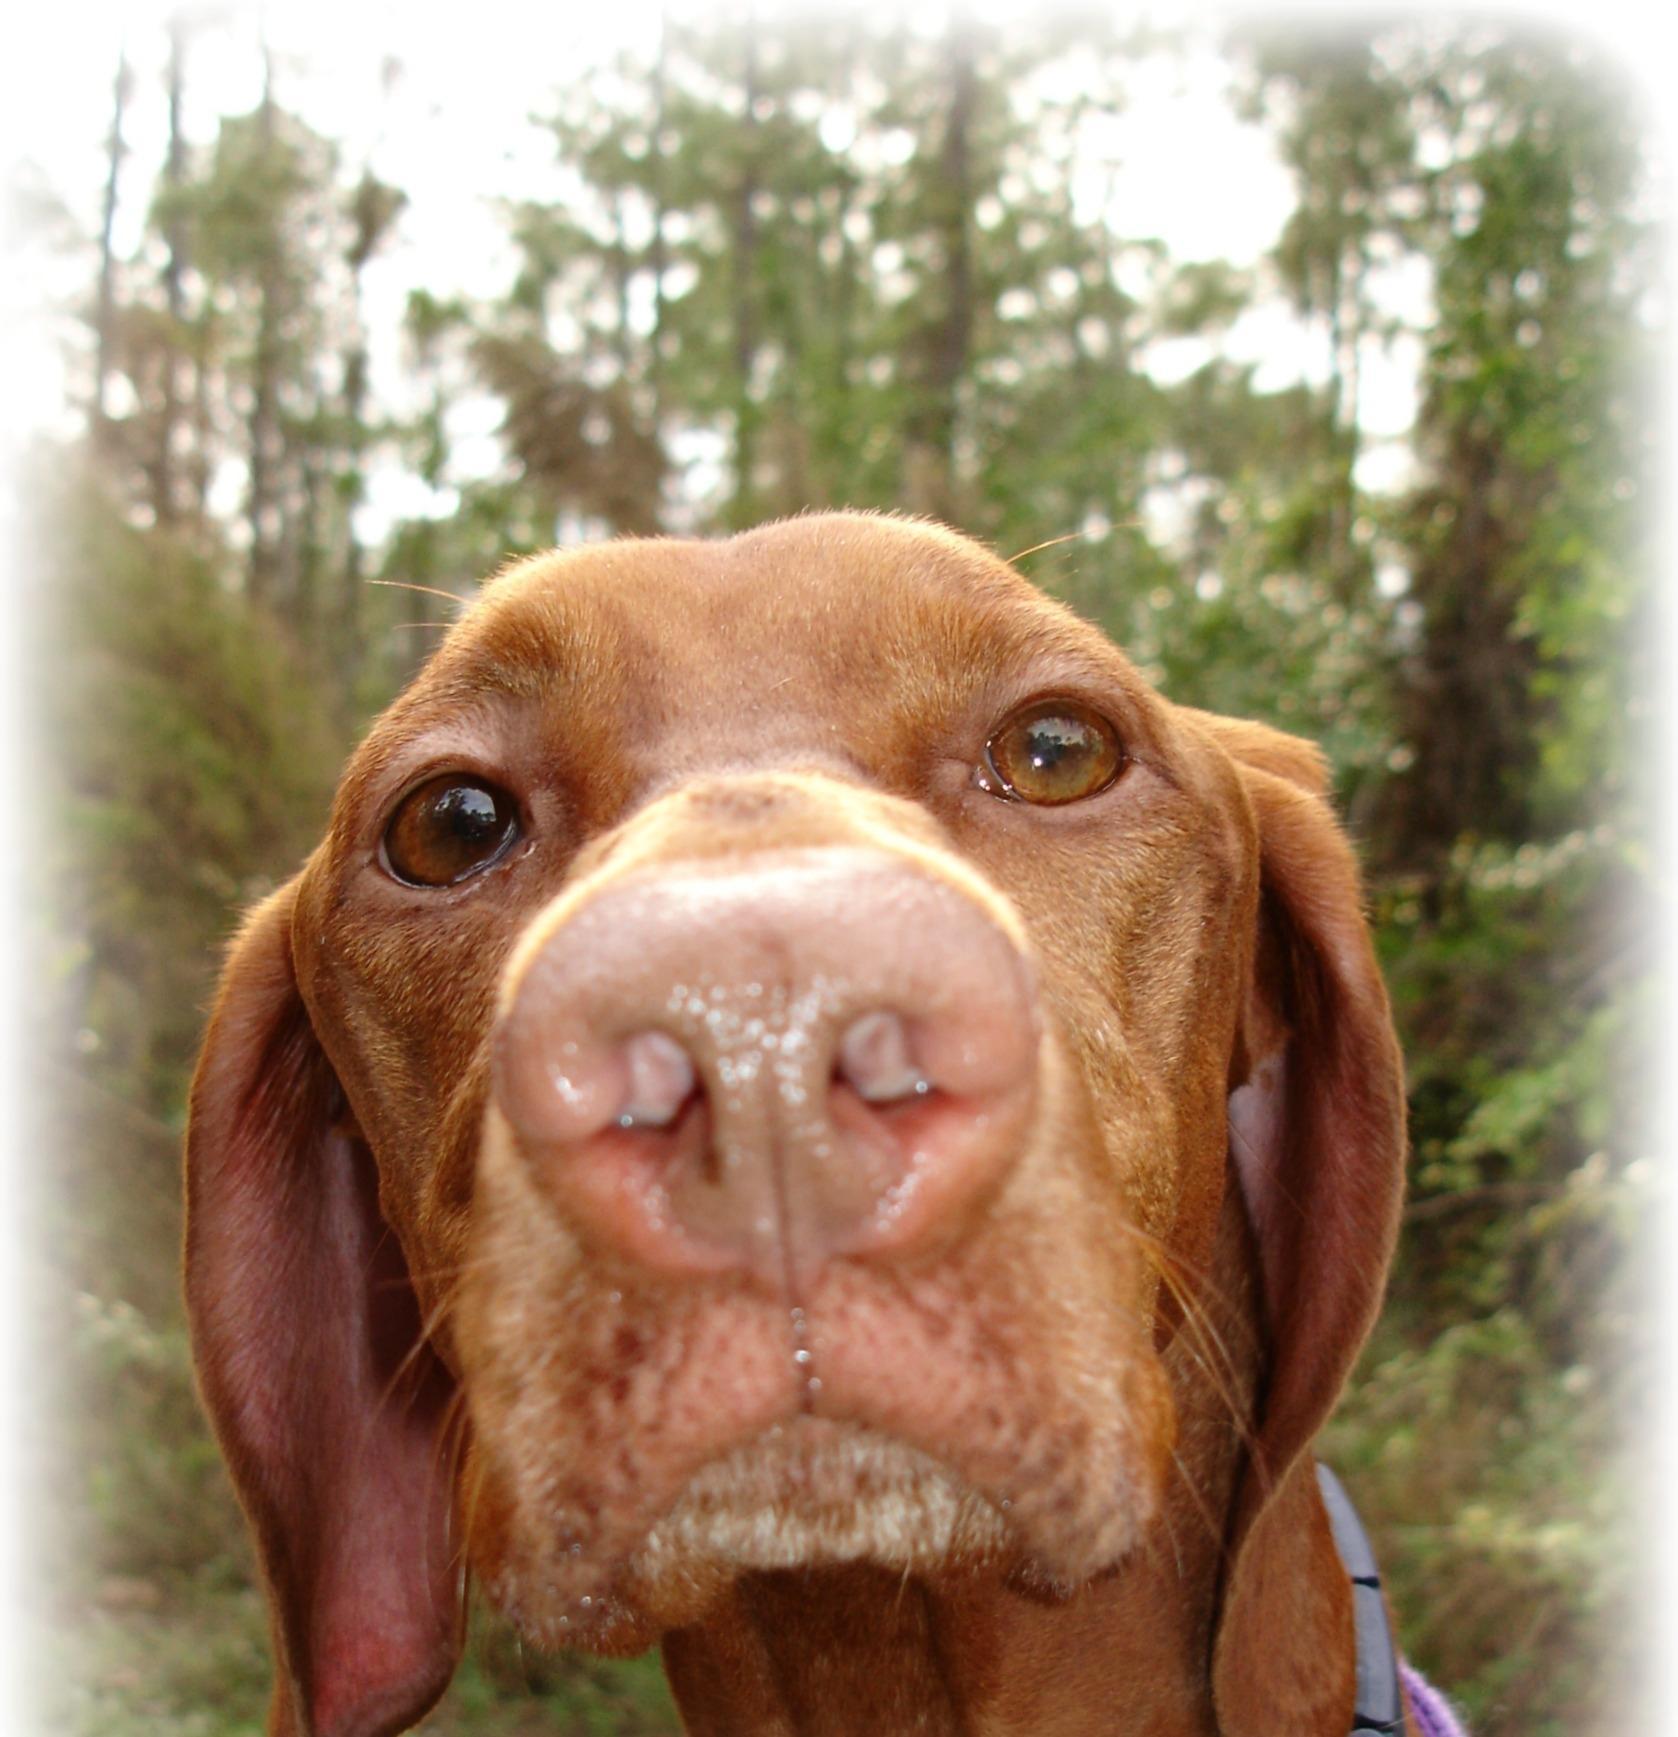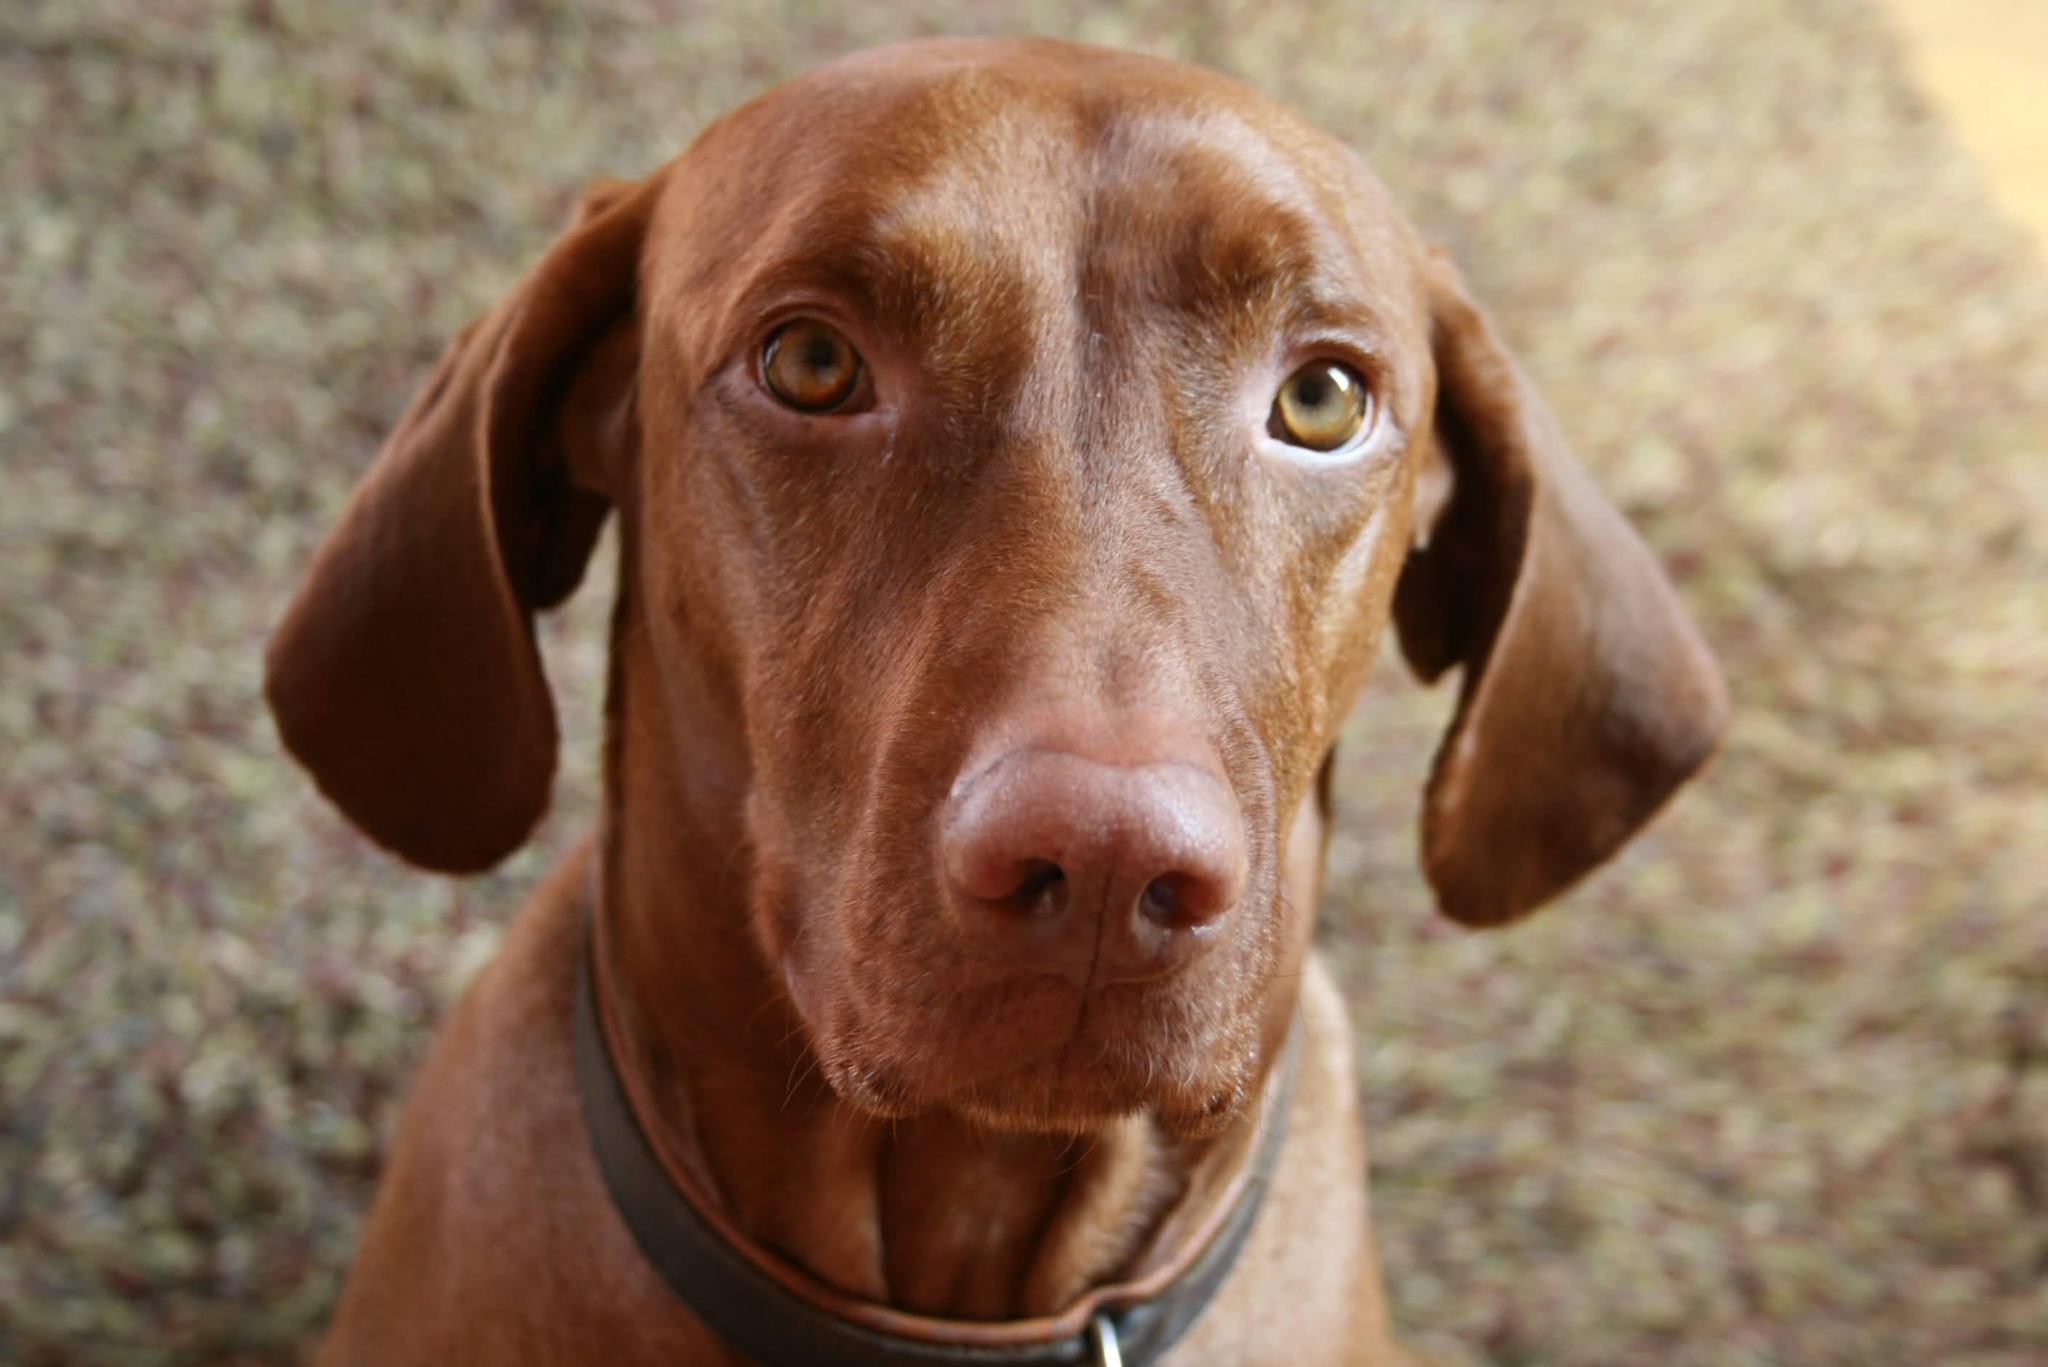The first image is the image on the left, the second image is the image on the right. Analyze the images presented: Is the assertion "There are two dogs looking forward at the camera" valid? Answer yes or no. Yes. The first image is the image on the left, the second image is the image on the right. For the images displayed, is the sentence "Each image contains a single dog, and each dog pictured is facing forward with its head upright and both eyes visible." factually correct? Answer yes or no. Yes. 